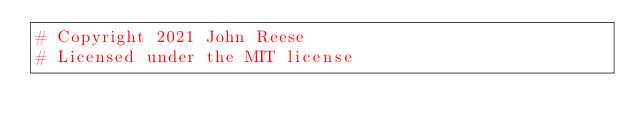Convert code to text. <code><loc_0><loc_0><loc_500><loc_500><_Python_># Copyright 2021 John Reese
# Licensed under the MIT license
</code> 